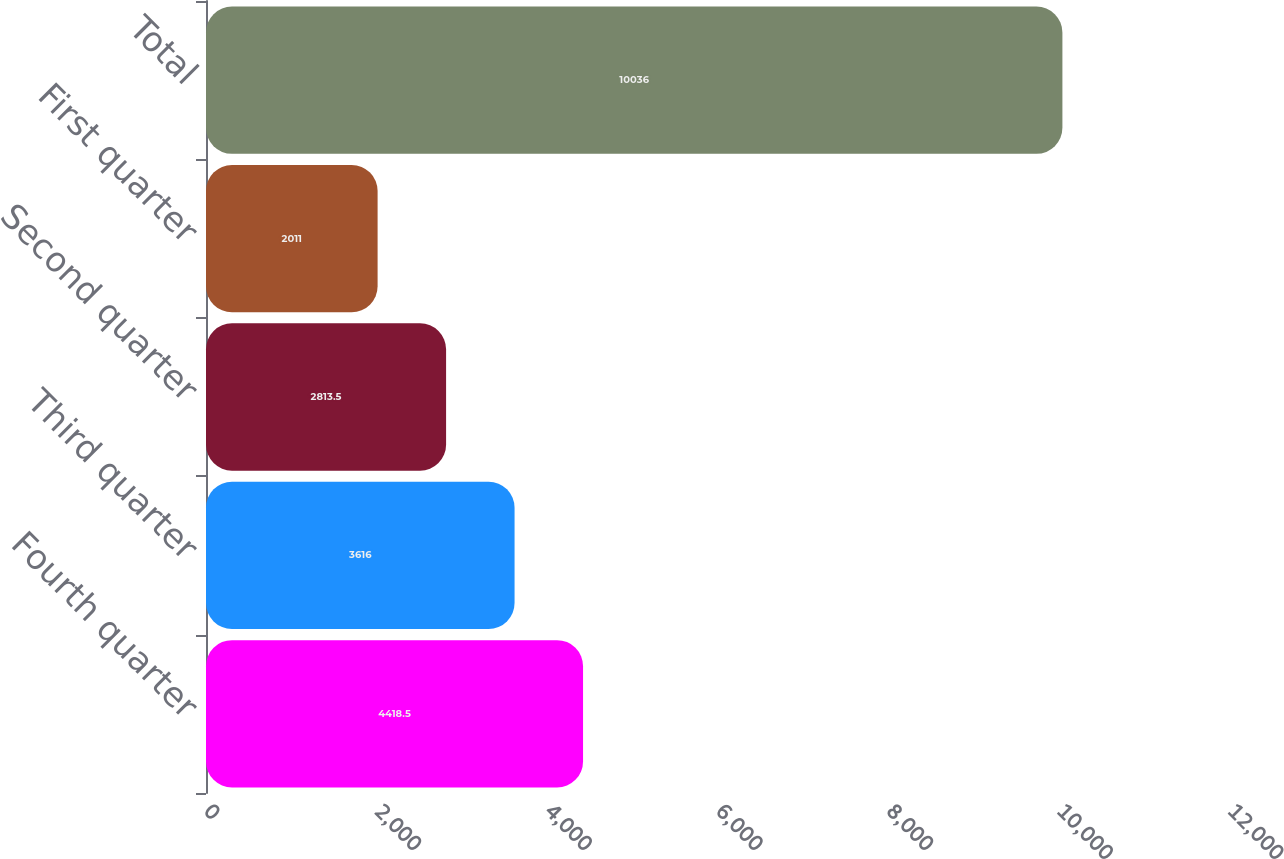Convert chart. <chart><loc_0><loc_0><loc_500><loc_500><bar_chart><fcel>Fourth quarter<fcel>Third quarter<fcel>Second quarter<fcel>First quarter<fcel>Total<nl><fcel>4418.5<fcel>3616<fcel>2813.5<fcel>2011<fcel>10036<nl></chart> 